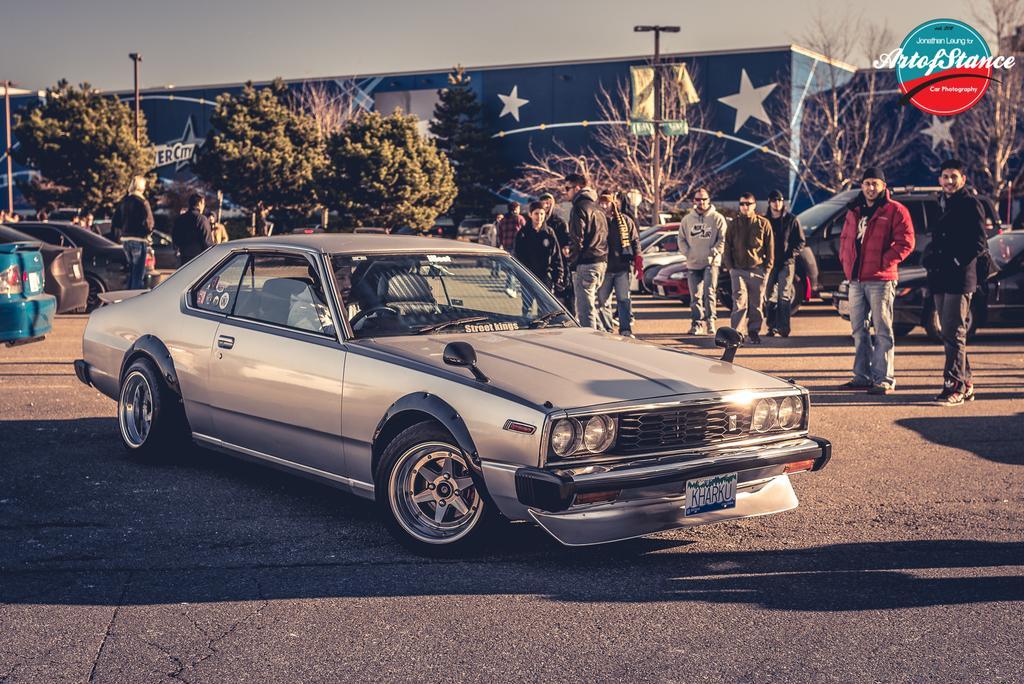Can you describe this image briefly? In this picture we can see a car in the front, in the background there are some trees and a building, we can see some people are standing in the middle, we can also see some cars and poles in the background, there is the sky at the top of the picture, at the right top of the picture there is a logo and some text. 